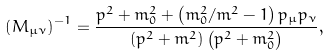Convert formula to latex. <formula><loc_0><loc_0><loc_500><loc_500>\left ( M _ { \mu \nu } \right ) ^ { - 1 } = \frac { p ^ { 2 } + m _ { 0 } ^ { 2 } + \left ( m _ { 0 } ^ { 2 } / m ^ { 2 } - 1 \right ) p _ { \mu } p _ { \nu } } { \left ( p ^ { 2 } + m ^ { 2 } \right ) \left ( p ^ { 2 } + m _ { 0 } ^ { 2 } \right ) } ,</formula> 